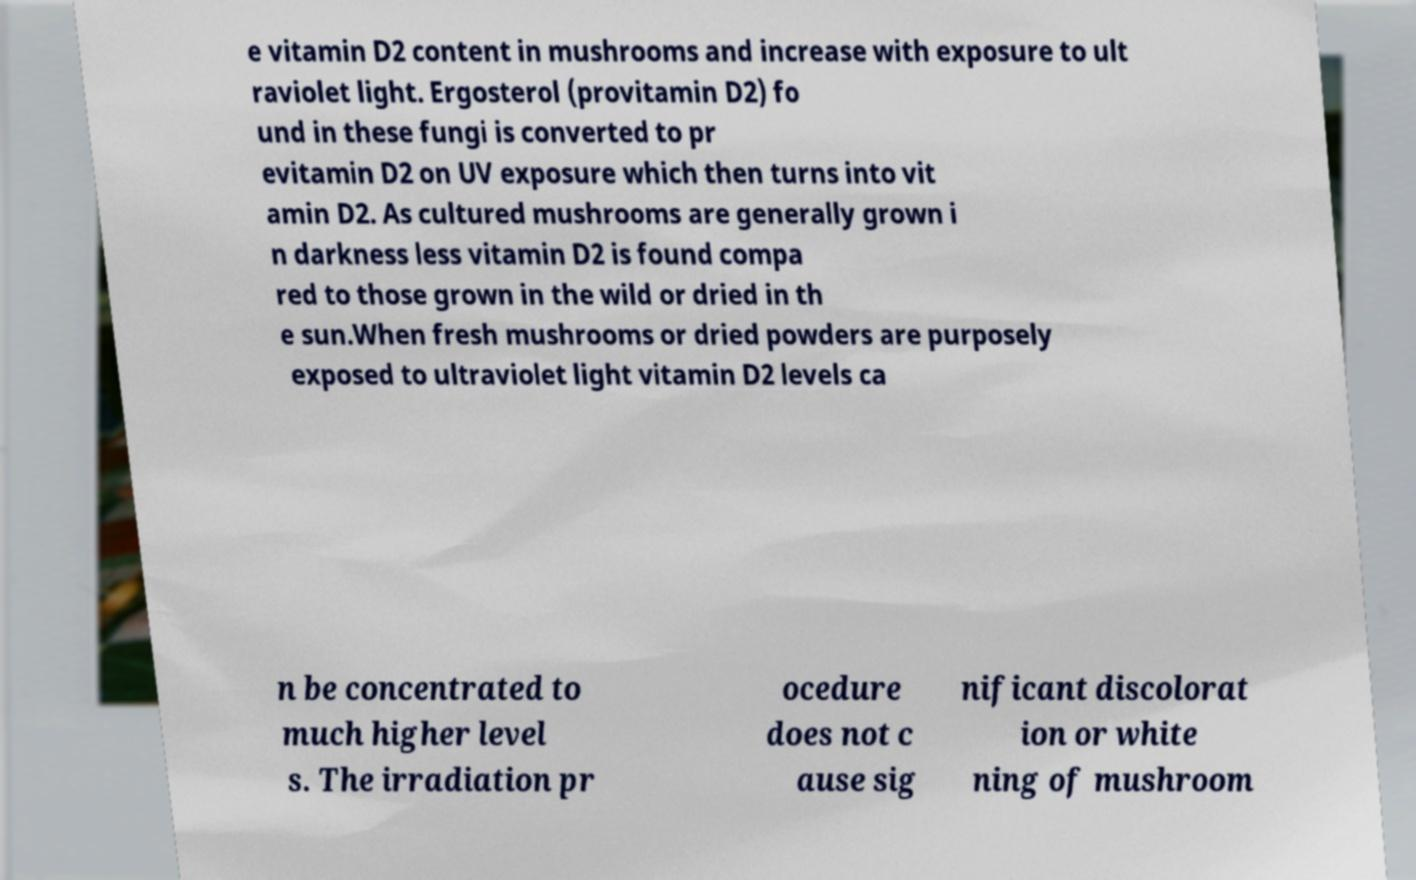Please read and relay the text visible in this image. What does it say? e vitamin D2 content in mushrooms and increase with exposure to ult raviolet light. Ergosterol (provitamin D2) fo und in these fungi is converted to pr evitamin D2 on UV exposure which then turns into vit amin D2. As cultured mushrooms are generally grown i n darkness less vitamin D2 is found compa red to those grown in the wild or dried in th e sun.When fresh mushrooms or dried powders are purposely exposed to ultraviolet light vitamin D2 levels ca n be concentrated to much higher level s. The irradiation pr ocedure does not c ause sig nificant discolorat ion or white ning of mushroom 